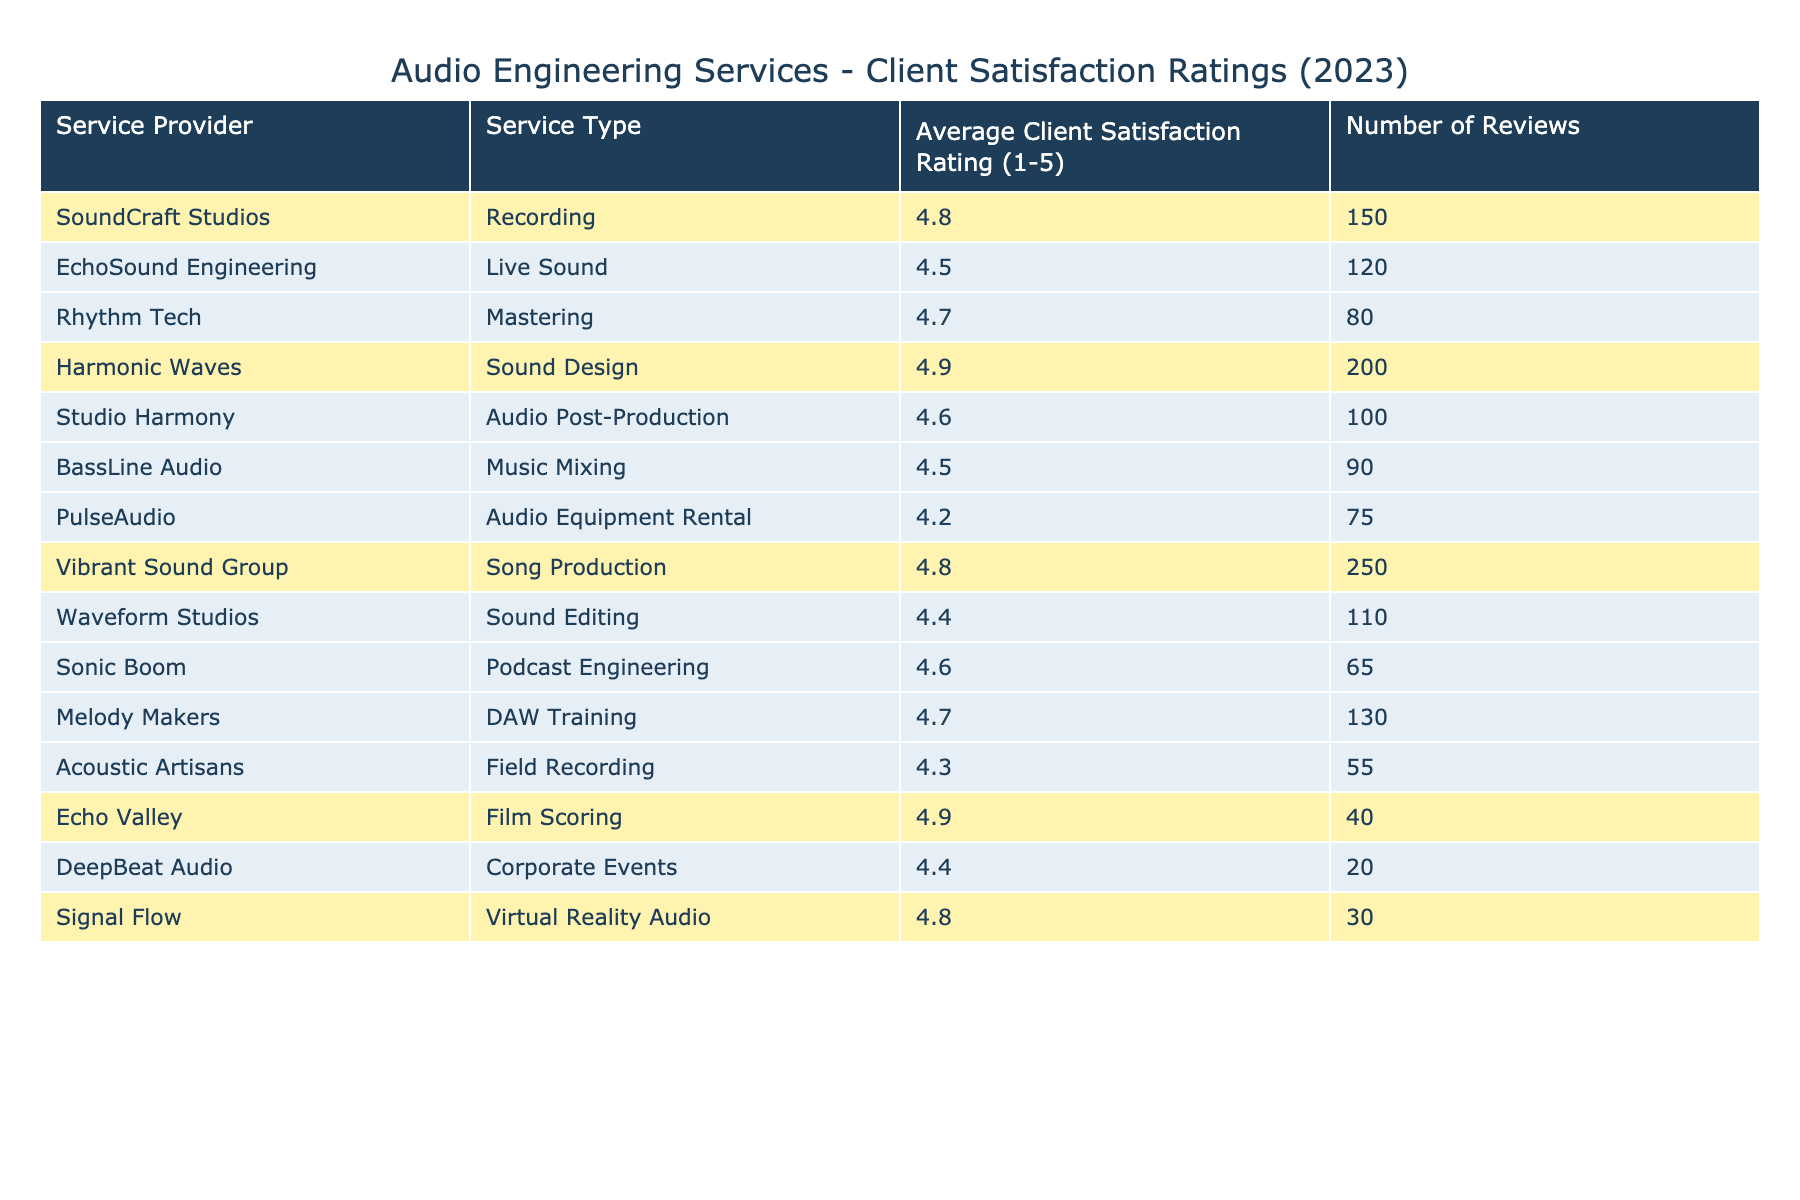What is the highest average client satisfaction rating among the service providers? The table lists the average client satisfaction ratings for different service providers and the highest rating is 4.9 from Harmonic Waves and Echo Valley.
Answer: 4.9 Which service provider has the lowest average client satisfaction rating? The table shows all the ratings and the lowest one is 4.2 from PulseAudio.
Answer: 4.2 How many reviews did Vibrant Sound Group receive? Looking at the table, Vibrant Sound Group has 250 reviews listed next to it.
Answer: 250 Is the average client satisfaction rating for Song Production higher than 4.5? Checking the value for Song Production in the table, its rating is 4.8, which is indeed higher than 4.5.
Answer: Yes What is the difference between the average satisfaction ratings of Harmonic Waves and EchoSound Engineering? Harmonic Waves has a rating of 4.9 and EchoSound Engineering has a rating of 4.5. The difference is 4.9 - 4.5 = 0.4.
Answer: 0.4 How many service providers have an average client satisfaction rating of 4.8? From the table, three service providers have a rating of 4.8: SoundCraft Studios, Vibrant Sound Group, and Signal Flow.
Answer: 3 Which service type has the highest number of reviews? By examining the table, Song Production by Vibrant Sound Group has the highest number of reviews at 250.
Answer: Song Production Is there a service provider with an average rating of 4.3? Yes, Acoustic Artisans has an average rating of 4.3 according to the table.
Answer: Yes What is the average client satisfaction rating of the highlighted service providers? The highlighted providers are SoundCraft Studios (4.8), Harmonic Waves (4.9), Vibrant Sound Group (4.8), and Echo Valley (4.9). Their average is (4.8 + 4.9 + 4.8 + 4.9) / 4 = 4.85.
Answer: 4.85 Which type of service has the highest satisfaction rating compared to others? Checking the table, Harmonic Waves offers Sound Design with the highest rating of 4.9.
Answer: Sound Design 